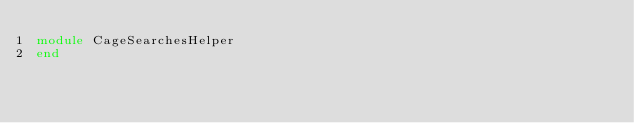Convert code to text. <code><loc_0><loc_0><loc_500><loc_500><_Ruby_>module CageSearchesHelper
end
</code> 